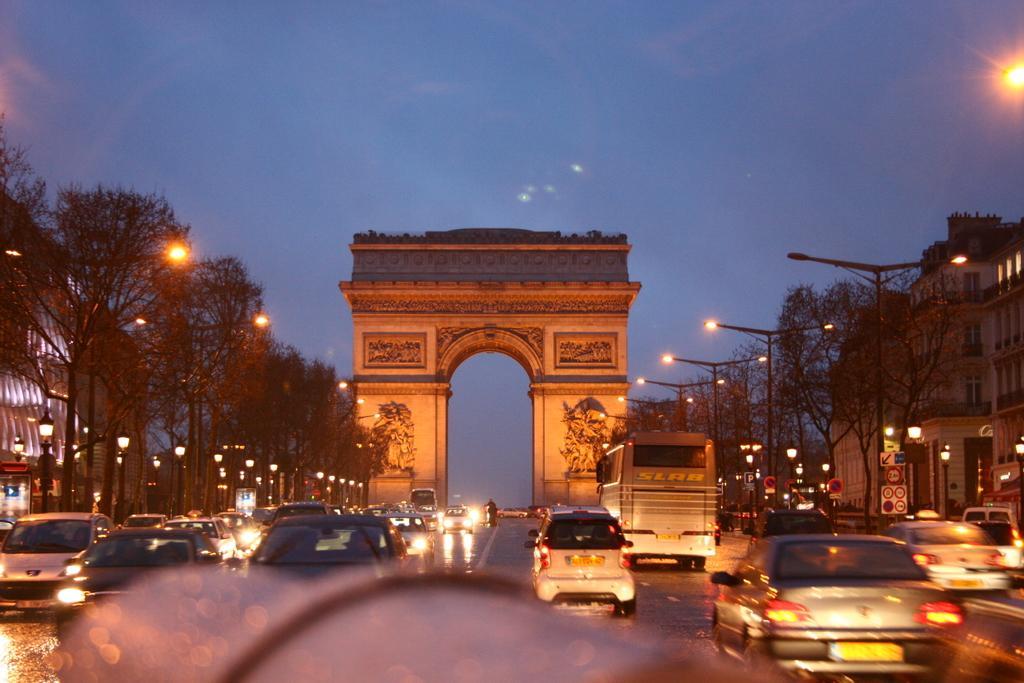Please provide a concise description of this image. At the center of the image there is an Arc. On the right and left side of the image there are buildings, trees and utility poles. In the middle of the image there is a road. On the road there are many vehicles passing. In the background of the image there is the sky. 